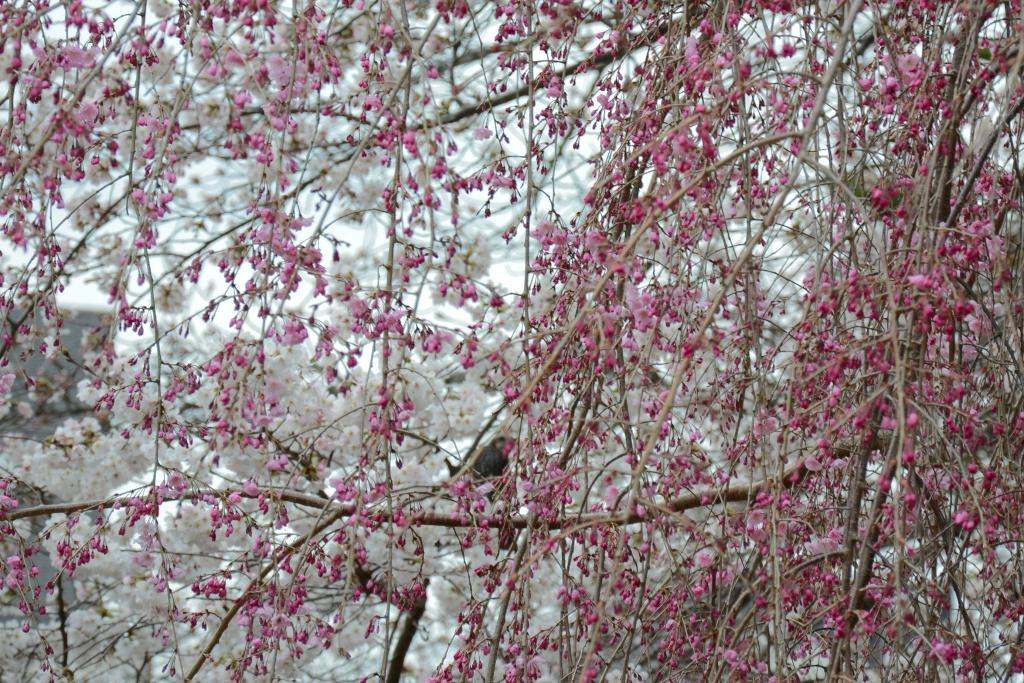What type of vegetation can be seen in the image? There are trees and flowers in the image. What stage of growth are some of the plants in the image? There are buds in the image, indicating that some plants are in the early stages of growth. What can be seen in the background of the image? The sky is visible in the background of the image. What type of plastic material can be seen in the image? There is no plastic material present in the image. What feeling of shame can be observed in the image? There is no indication of shame or any emotional state in the image, as it primarily features plants and the sky. 